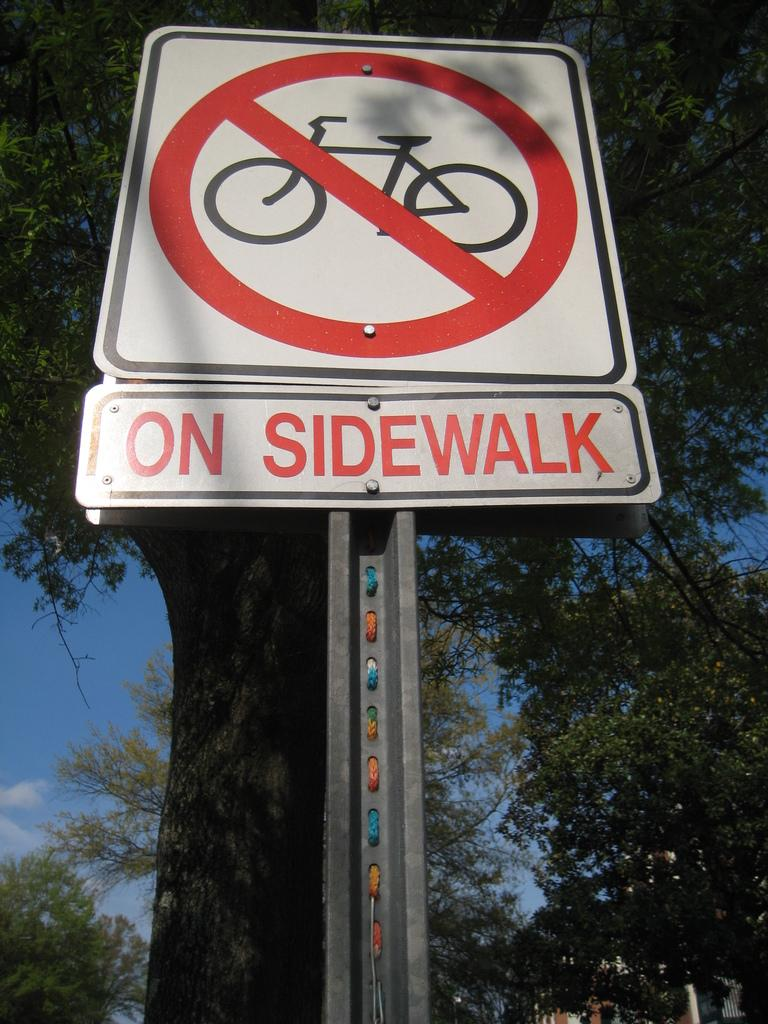<image>
Give a short and clear explanation of the subsequent image. a close up of a street sign reading On Sidewalk with a slash through a bike 